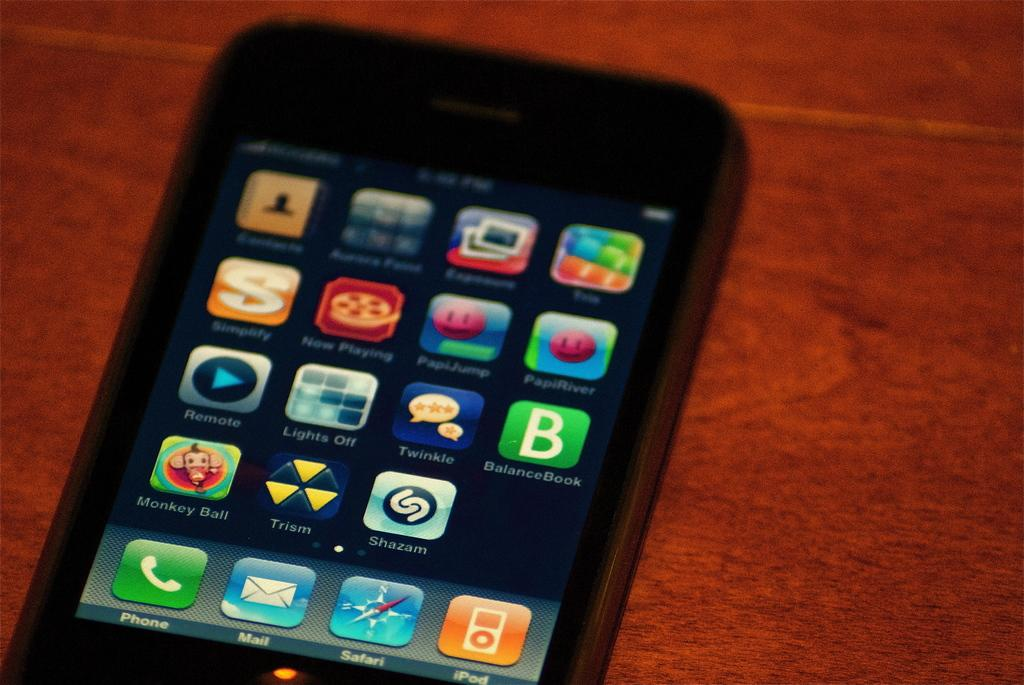<image>
Describe the image concisely. A smart phone has a number of apps installed including Monkey Ball. 